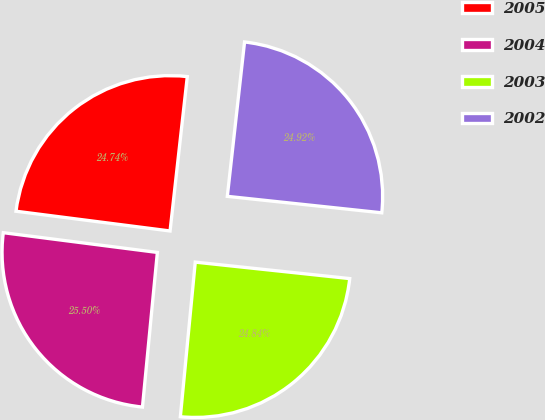Convert chart to OTSL. <chart><loc_0><loc_0><loc_500><loc_500><pie_chart><fcel>2005<fcel>2004<fcel>2003<fcel>2002<nl><fcel>24.74%<fcel>25.5%<fcel>24.84%<fcel>24.92%<nl></chart> 